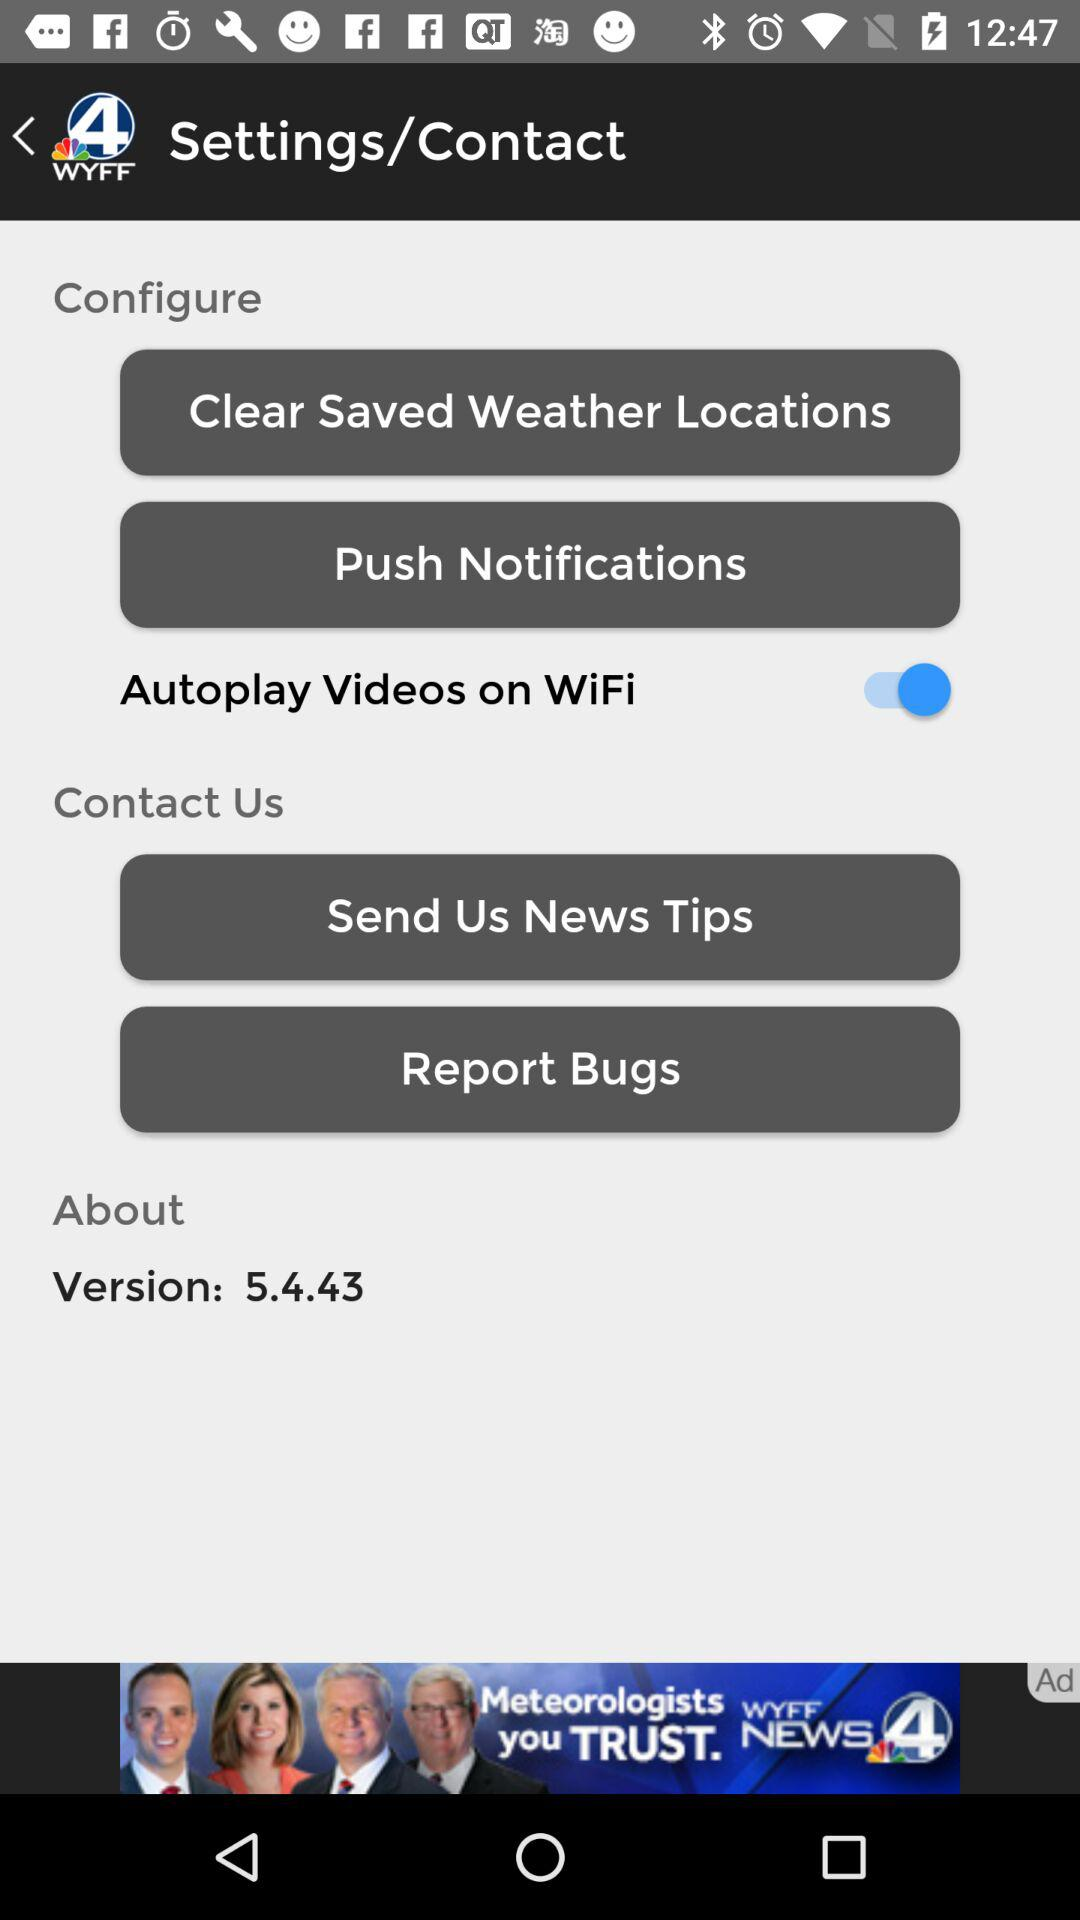What is the status of the "Autoplay Videos on WiFi" settings? The status is "on". 